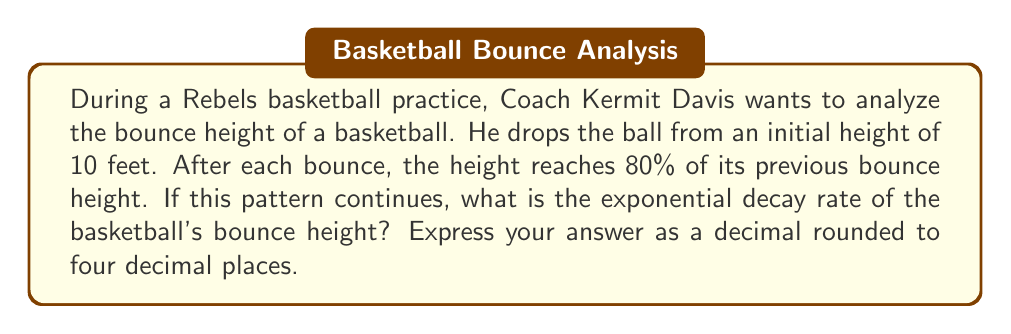What is the answer to this math problem? Let's approach this step-by-step:

1) The general form of an exponential decay function is:

   $$ h(t) = h_0 \cdot r^t $$

   Where $h_0$ is the initial height, $r$ is the decay rate, and $t$ is the number of bounces.

2) We're told that after each bounce, the height is 80% of the previous height. This means:

   $$ \frac{h(t+1)}{h(t)} = 0.80 $$

3) This ratio is our decay rate, $r$. However, we need to express this as a decay rate, not a retention rate. To do this, we subtract from 1:

   $$ r = 1 - 0.80 = 0.20 $$

4) Therefore, the exponential decay rate is 0.20 or 20%.

5) The complete function describing the bounce height after $t$ bounces would be:

   $$ h(t) = 10 \cdot (0.80)^t $$

   Where 10 is the initial height in feet, and 0.80 is the complement of the decay rate (1 - 0.20).
Answer: 0.2000 